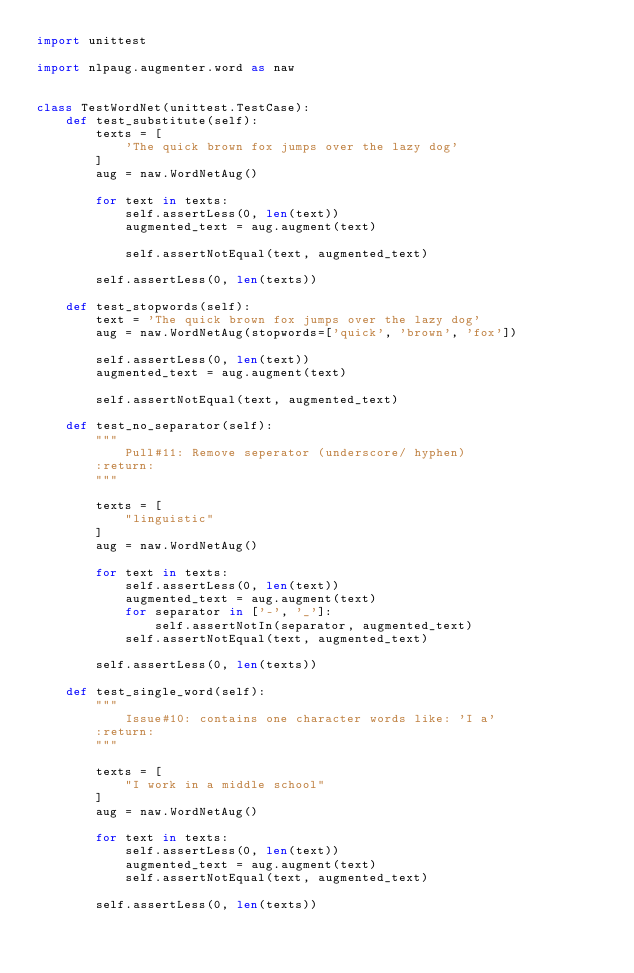Convert code to text. <code><loc_0><loc_0><loc_500><loc_500><_Python_>import unittest

import nlpaug.augmenter.word as naw


class TestWordNet(unittest.TestCase):
    def test_substitute(self):
        texts = [
            'The quick brown fox jumps over the lazy dog'
        ]
        aug = naw.WordNetAug()

        for text in texts:
            self.assertLess(0, len(text))
            augmented_text = aug.augment(text)

            self.assertNotEqual(text, augmented_text)

        self.assertLess(0, len(texts))

    def test_stopwords(self):
        text = 'The quick brown fox jumps over the lazy dog'
        aug = naw.WordNetAug(stopwords=['quick', 'brown', 'fox'])

        self.assertLess(0, len(text))
        augmented_text = aug.augment(text)

        self.assertNotEqual(text, augmented_text)

    def test_no_separator(self):
        """
            Pull#11: Remove seperator (underscore/ hyphen)
        :return:
        """

        texts = [
            "linguistic"
        ]
        aug = naw.WordNetAug()

        for text in texts:
            self.assertLess(0, len(text))
            augmented_text = aug.augment(text)
            for separator in ['-', '_']:
                self.assertNotIn(separator, augmented_text)
            self.assertNotEqual(text, augmented_text)

        self.assertLess(0, len(texts))

    def test_single_word(self):
        """
            Issue#10: contains one character words like: 'I a'
        :return:
        """

        texts = [
            "I work in a middle school"
        ]
        aug = naw.WordNetAug()

        for text in texts:
            self.assertLess(0, len(text))
            augmented_text = aug.augment(text)
            self.assertNotEqual(text, augmented_text)

        self.assertLess(0, len(texts))
</code> 